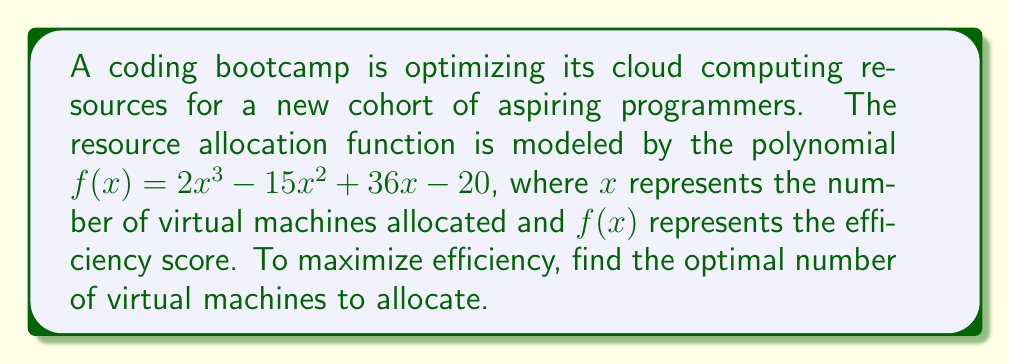Help me with this question. To find the optimal number of virtual machines, we need to find the maximum value of the function $f(x)$. This occurs where the derivative $f'(x) = 0$.

Step 1: Find the derivative of $f(x)$
$$f'(x) = 6x^2 - 30x + 36$$

Step 2: Set $f'(x) = 0$ and solve the resulting quadratic equation
$$6x^2 - 30x + 36 = 0$$

Step 3: Factor the quadratic equation
$$6(x^2 - 5x + 6) = 0$$
$$6(x - 2)(x - 3) = 0$$

Step 4: Solve for x
$$x = 2 \text{ or } x = 3$$

Step 5: Check the second derivative to confirm maximum
$$f''(x) = 12x - 30$$
At $x = 2$: $f''(2) = -6 < 0$
At $x = 3$: $f''(3) = 6 > 0$

Therefore, the maximum occurs at $x = 2$.

Step 6: Verify by comparing $f(2)$ and $f(3)$
$$f(2) = 2(2)^3 - 15(2)^2 + 36(2) - 20 = 16 - 60 + 72 - 20 = 8$$
$$f(3) = 2(3)^3 - 15(3)^2 + 36(3) - 20 = 54 - 135 + 108 - 20 = 7$$

This confirms that $x = 2$ gives the maximum value.
Answer: 2 virtual machines 